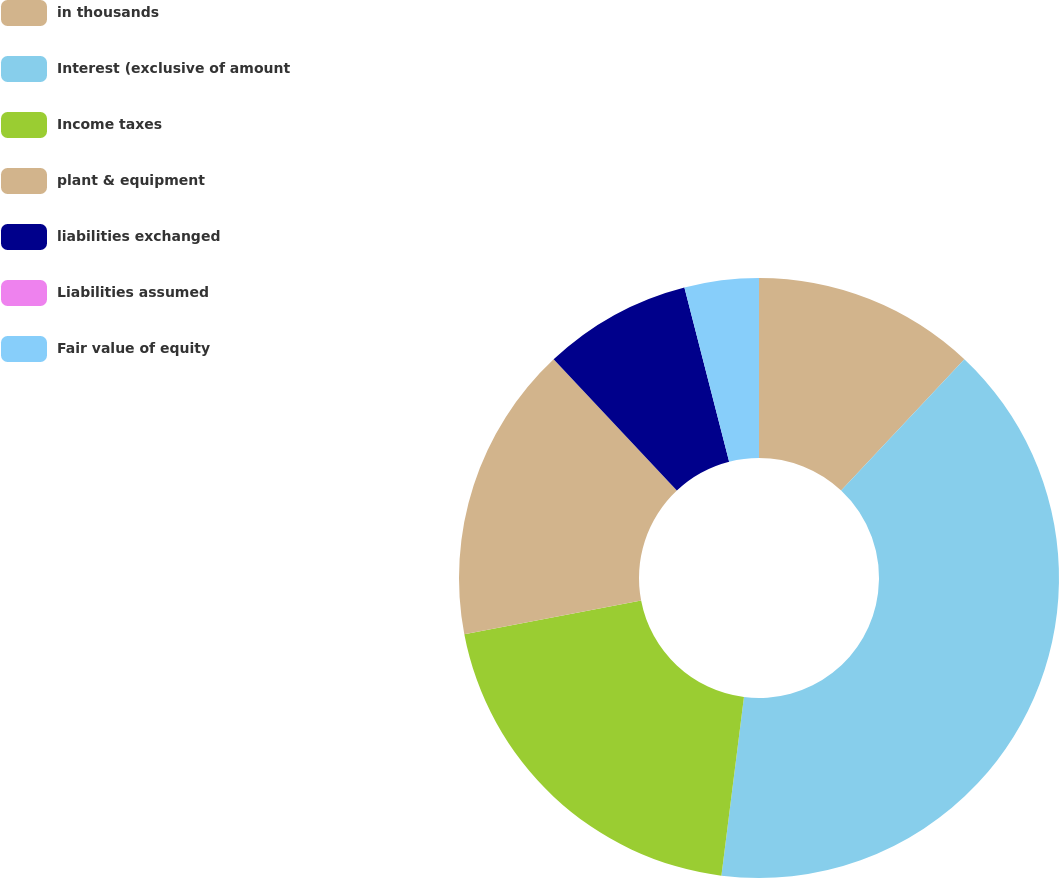<chart> <loc_0><loc_0><loc_500><loc_500><pie_chart><fcel>in thousands<fcel>Interest (exclusive of amount<fcel>Income taxes<fcel>plant & equipment<fcel>liabilities exchanged<fcel>Liabilities assumed<fcel>Fair value of equity<nl><fcel>12.0%<fcel>40.0%<fcel>20.0%<fcel>16.0%<fcel>8.0%<fcel>0.0%<fcel>4.0%<nl></chart> 